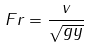Convert formula to latex. <formula><loc_0><loc_0><loc_500><loc_500>F r = \frac { v } { \sqrt { g y } }</formula> 